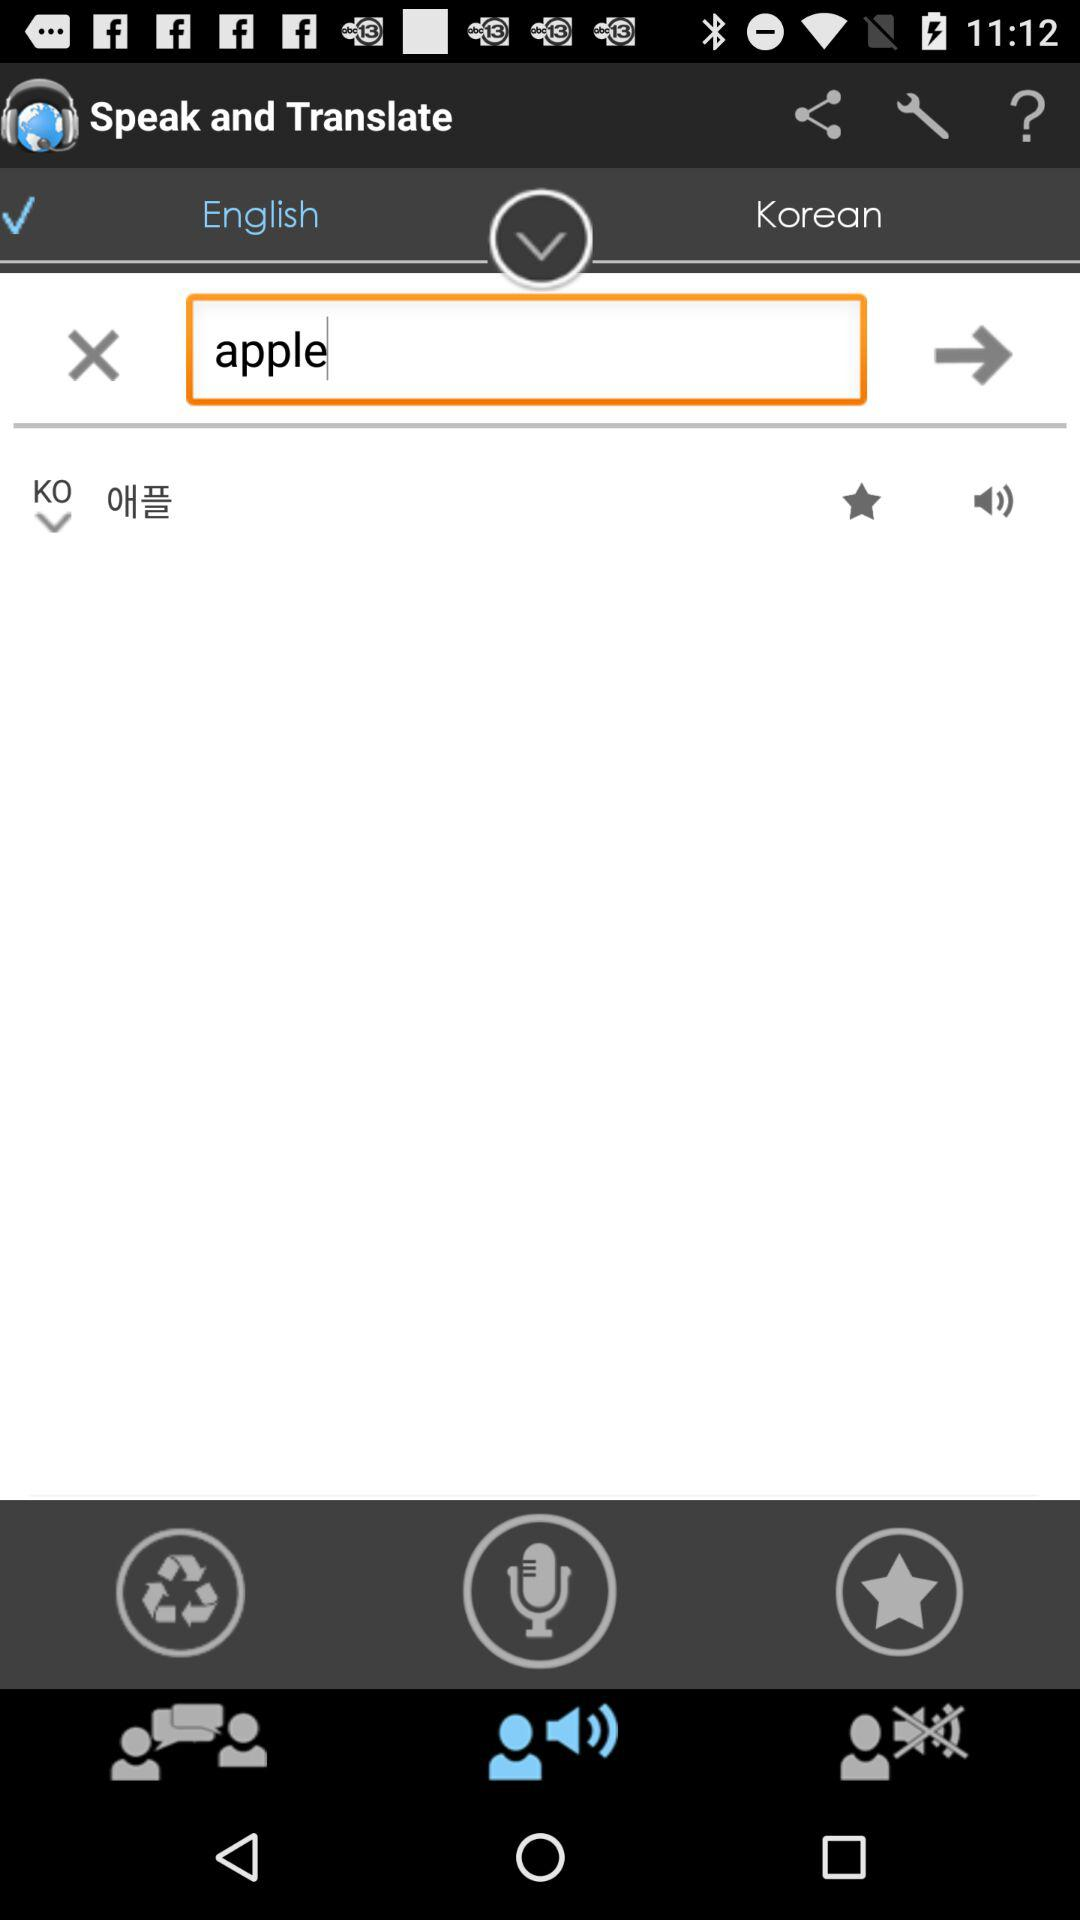What is the application name? The application name is "Speak and Translate". 